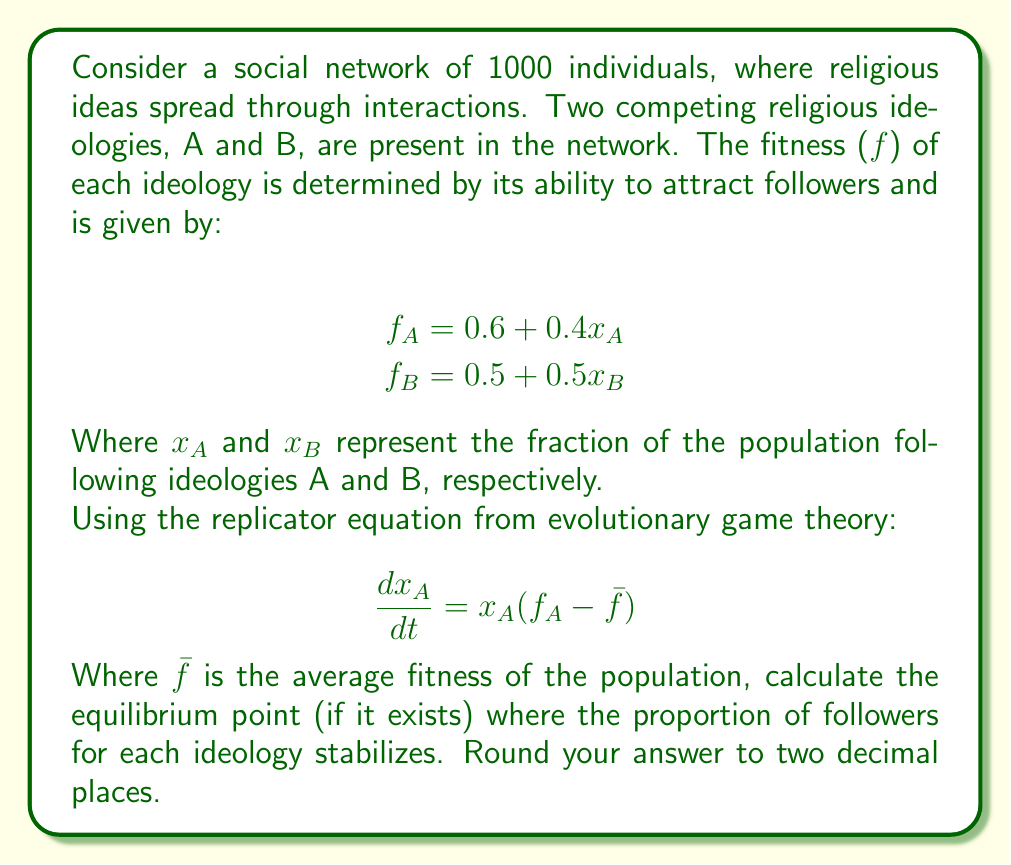Solve this math problem. To solve this problem, we'll follow these steps:

1) First, note that $x_A + x_B = 1$ since these are the only two ideologies in the population.

2) The average fitness $\bar{f}$ is given by:
   $\bar{f} = x_Af_A + x_Bf_B$

3) Substitute the fitness functions:
   $\bar{f} = x_A(0.6 + 0.4x_A) + (1-x_A)(0.5 + 0.5(1-x_A))$

4) Simplify:
   $\bar{f} = 0.6x_A + 0.4x_A^2 + 0.5 - 0.5x_A + 0.5 - 0.5x_A + 0.5x_A^2$
   $\bar{f} = 0.9x_A^2 - 0.4x_A + 1$

5) At equilibrium, $\frac{dx_A}{dt} = 0$, which means $f_A = \bar{f}$

6) Set up the equation:
   $0.6 + 0.4x_A = 0.9x_A^2 - 0.4x_A + 1$

7) Simplify:
   $0.9x_A^2 - 0.8x_A - 0.4 = 0$

8) This is a quadratic equation. Solve using the quadratic formula:
   $x_A = \frac{0.8 \pm \sqrt{0.64 + 1.44}}{1.8}$
   $x_A = \frac{0.8 \pm \sqrt{2.08}}{1.8}$
   $x_A = \frac{0.8 \pm 1.44}{1.8}$

9) This gives us two solutions:
   $x_A = \frac{0.8 + 1.44}{1.8} = 1.24$ (discard as it's > 1)
   $x_A = \frac{0.8 - 1.44}{1.8} = -0.36$ (discard as it's < 0)

10) Since both solutions are outside the valid range for a proportion, there is no stable equilibrium point within the system.

11) This suggests that one ideology will eventually dominate. To determine which one, we can compare their fitness at the extremes:

    When $x_A = 1$: $f_A = 1$
    When $x_B = 1$: $f_B = 1$

    Both ideologies have the same maximum fitness, but ideology A has a higher base fitness (0.6 vs 0.5). This suggests that ideology A will eventually dominate.
Answer: There is no stable equilibrium point. Ideology A will eventually dominate the population, approaching a proportion of 1.00. 